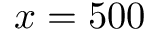Convert formula to latex. <formula><loc_0><loc_0><loc_500><loc_500>x = 5 0 0</formula> 